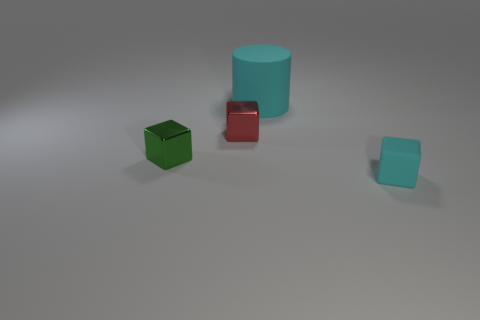What number of tiny purple objects have the same shape as the red metallic object?
Keep it short and to the point. 0. How many large rubber things are the same color as the tiny matte object?
Offer a terse response. 1. There is a cyan matte object in front of the big cyan cylinder; is it the same shape as the green object that is in front of the large matte object?
Your answer should be compact. Yes. What number of tiny cyan things are in front of the cyan thing behind the tiny block on the right side of the large cyan thing?
Offer a very short reply. 1. There is a thing that is to the right of the cyan object that is to the left of the tiny object that is on the right side of the large cylinder; what is it made of?
Provide a succinct answer. Rubber. Does the tiny red thing on the right side of the green cube have the same material as the cyan cylinder?
Your response must be concise. No. What number of other shiny things are the same size as the red object?
Offer a very short reply. 1. Is the number of cylinders in front of the large thing greater than the number of tiny red shiny blocks that are behind the red cube?
Provide a short and direct response. No. Is there a small brown metallic object of the same shape as the big cyan thing?
Ensure brevity in your answer.  No. There is a cyan thing that is behind the tiny cube in front of the small green cube; what is its size?
Provide a short and direct response. Large. 